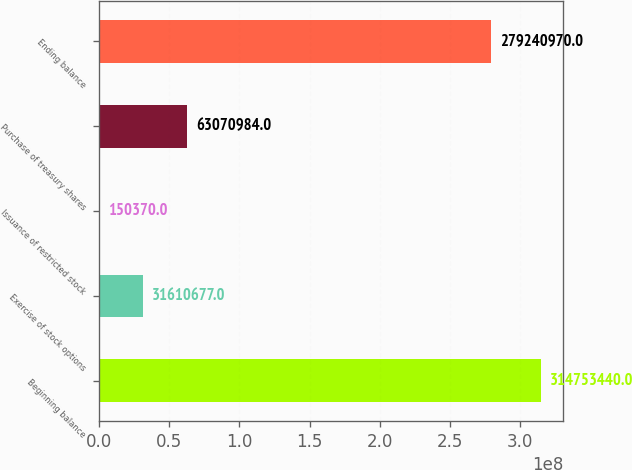Convert chart. <chart><loc_0><loc_0><loc_500><loc_500><bar_chart><fcel>Beginning balance<fcel>Exercise of stock options<fcel>Issuance of restricted stock<fcel>Purchase of treasury shares<fcel>Ending balance<nl><fcel>3.14753e+08<fcel>3.16107e+07<fcel>150370<fcel>6.3071e+07<fcel>2.79241e+08<nl></chart> 